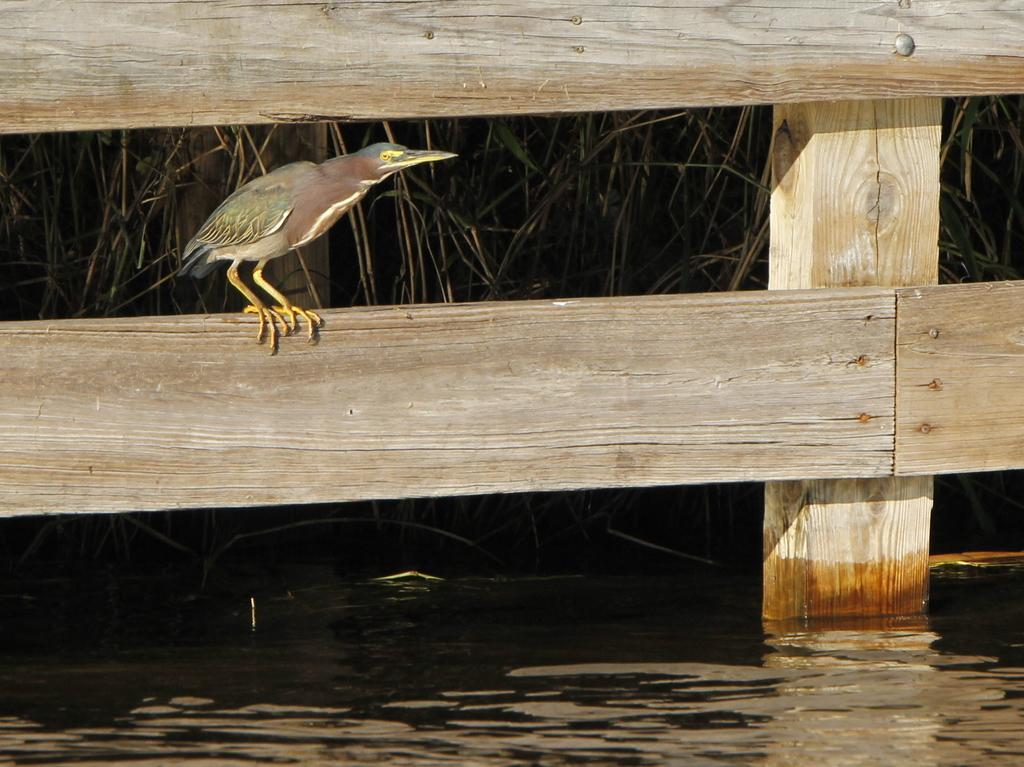Could you give a brief overview of what you see in this image? In this picture there is a bird standing on the wooden railing. There are plants behind the railing. At the bottom there is water. 